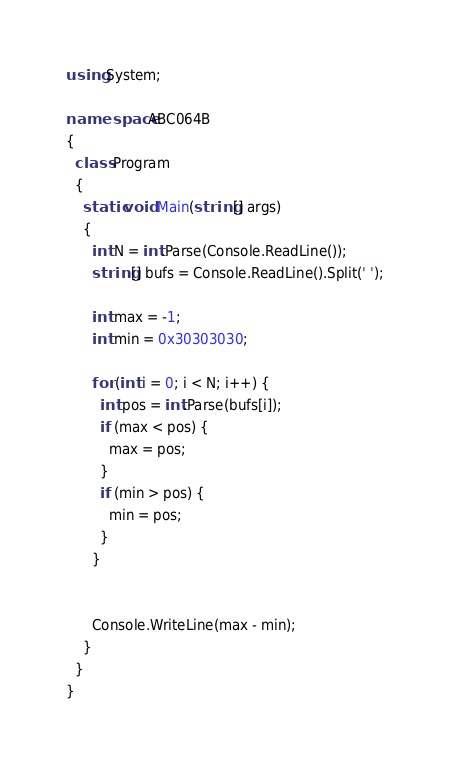Convert code to text. <code><loc_0><loc_0><loc_500><loc_500><_C#_>using System;

namespace ABC064B
{
  class Program
  {
    static void Main(string[] args)
    {
      int N = int.Parse(Console.ReadLine());
      string[] bufs = Console.ReadLine().Split(' ');

      int max = -1;
      int min = 0x30303030;

      for (int i = 0; i < N; i++) {
        int pos = int.Parse(bufs[i]);
        if (max < pos) {
          max = pos;
        }
        if (min > pos) {
          min = pos;
        }
      }


      Console.WriteLine(max - min);
    }
  }
}
</code> 